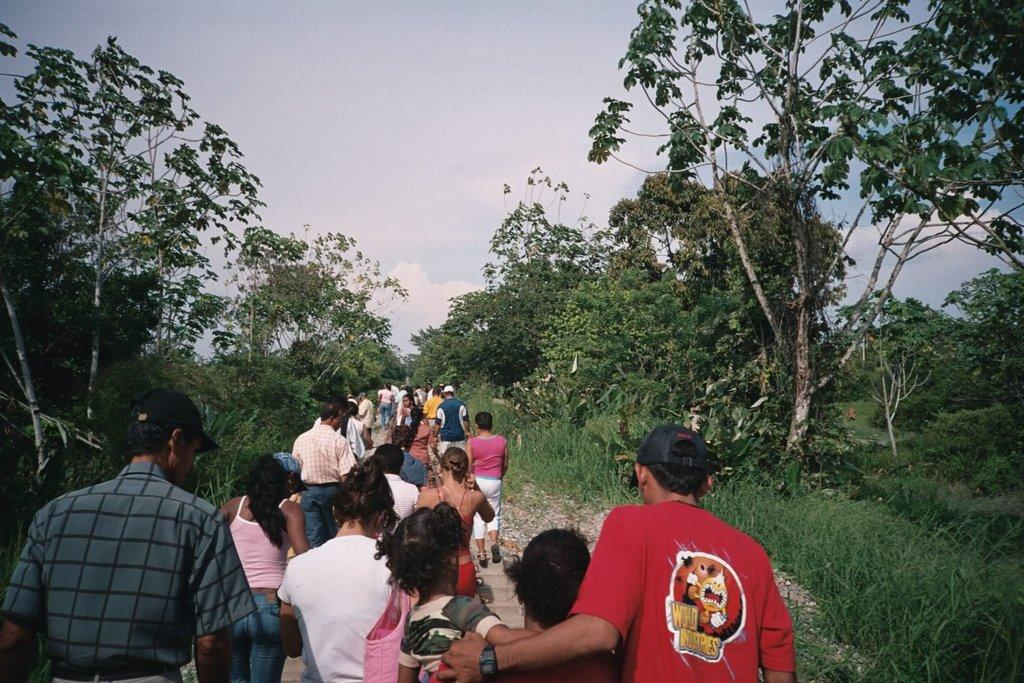What are the persons in the image doing? The persons in the image are walking. What can be seen beside the persons? There are trees beside the persons. What is visible in the background of the image? The sky is visible in the image. Can you tell me how many rays are shining through the trees in the image? There are no rays shining through the trees in the image; it only shows persons walking and trees beside them. 